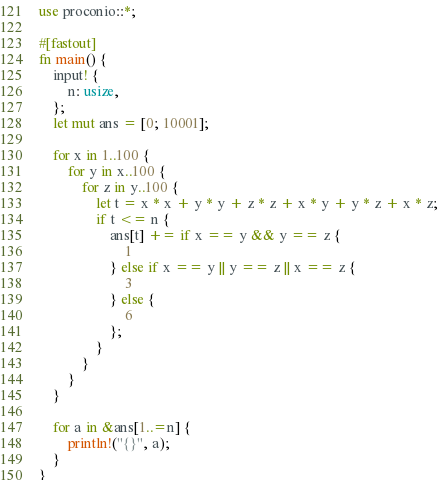<code> <loc_0><loc_0><loc_500><loc_500><_Rust_>use proconio::*;

#[fastout]
fn main() {
    input! {
        n: usize,
    };
    let mut ans = [0; 10001];

    for x in 1..100 {
        for y in x..100 {
            for z in y..100 {
                let t = x * x + y * y + z * z + x * y + y * z + x * z;
                if t <= n {
                    ans[t] += if x == y && y == z {
                        1
                    } else if x == y || y == z || x == z {
                        3
                    } else {
                        6
                    };
                }
            }
        }
    }

    for a in &ans[1..=n] {
        println!("{}", a);
    }
}
</code> 